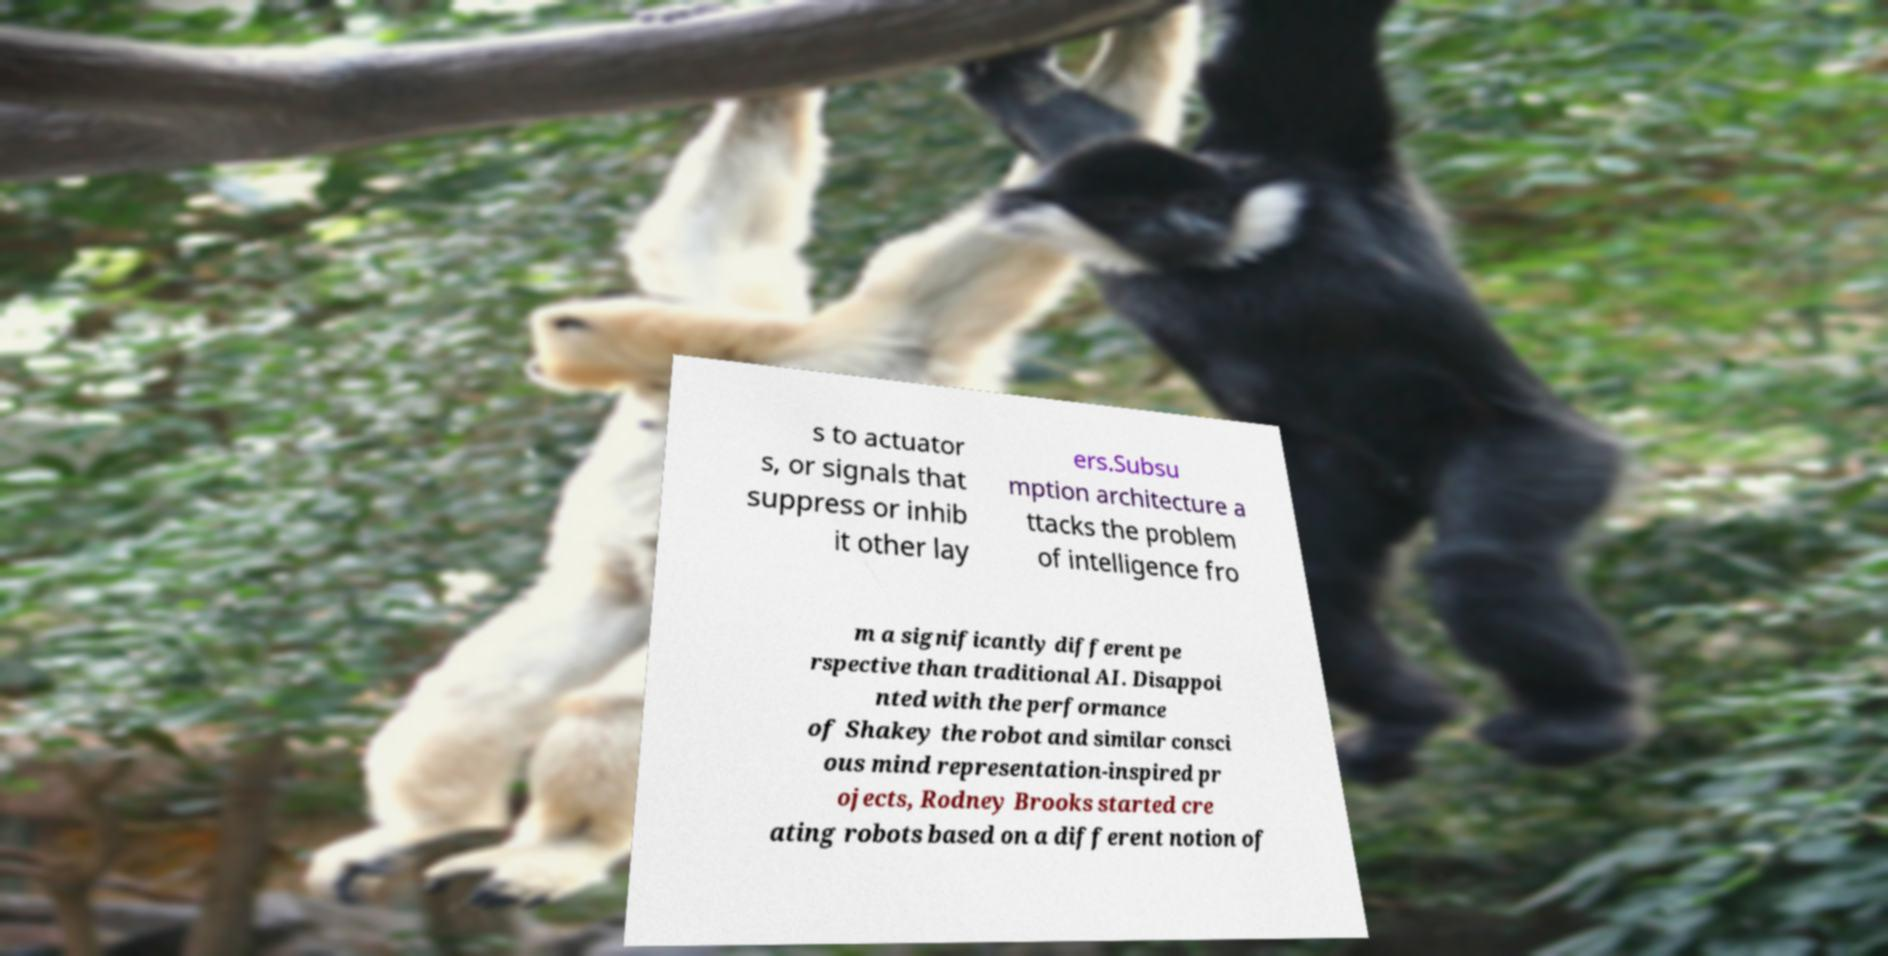There's text embedded in this image that I need extracted. Can you transcribe it verbatim? s to actuator s, or signals that suppress or inhib it other lay ers.Subsu mption architecture a ttacks the problem of intelligence fro m a significantly different pe rspective than traditional AI. Disappoi nted with the performance of Shakey the robot and similar consci ous mind representation-inspired pr ojects, Rodney Brooks started cre ating robots based on a different notion of 